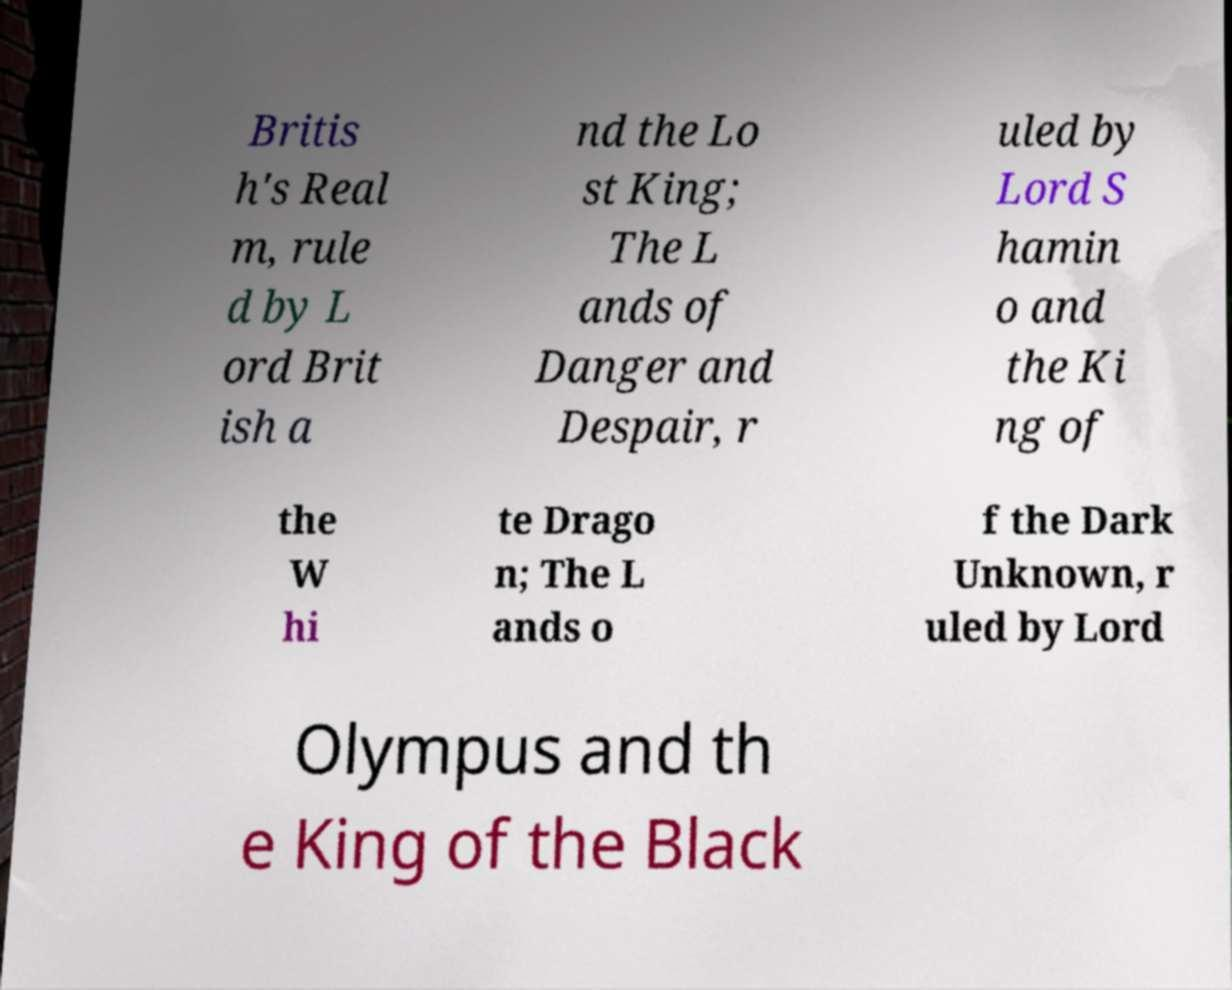Can you accurately transcribe the text from the provided image for me? Britis h's Real m, rule d by L ord Brit ish a nd the Lo st King; The L ands of Danger and Despair, r uled by Lord S hamin o and the Ki ng of the W hi te Drago n; The L ands o f the Dark Unknown, r uled by Lord Olympus and th e King of the Black 